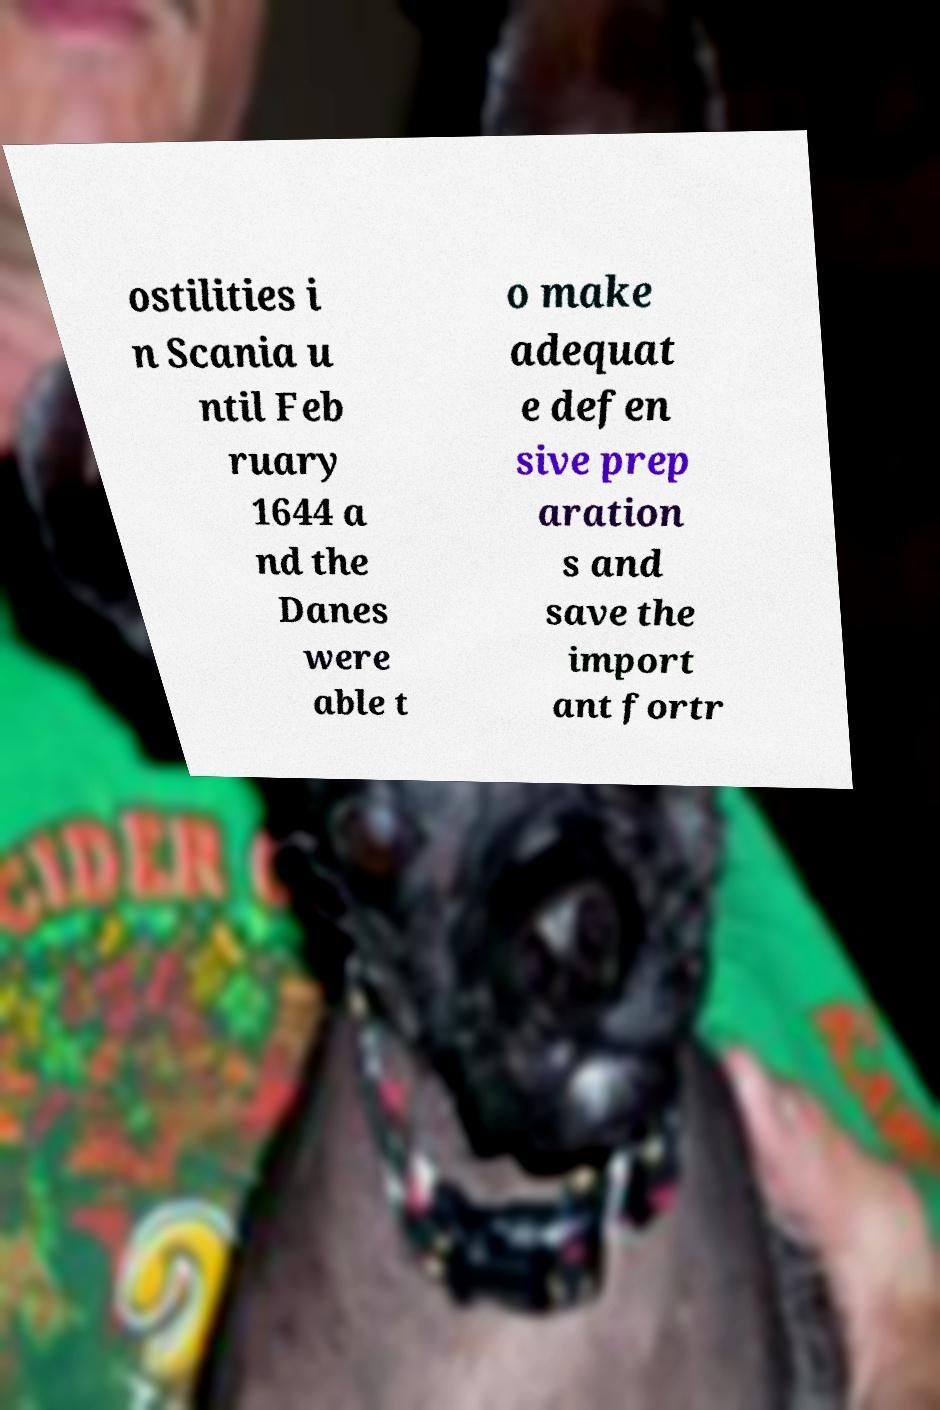I need the written content from this picture converted into text. Can you do that? ostilities i n Scania u ntil Feb ruary 1644 a nd the Danes were able t o make adequat e defen sive prep aration s and save the import ant fortr 